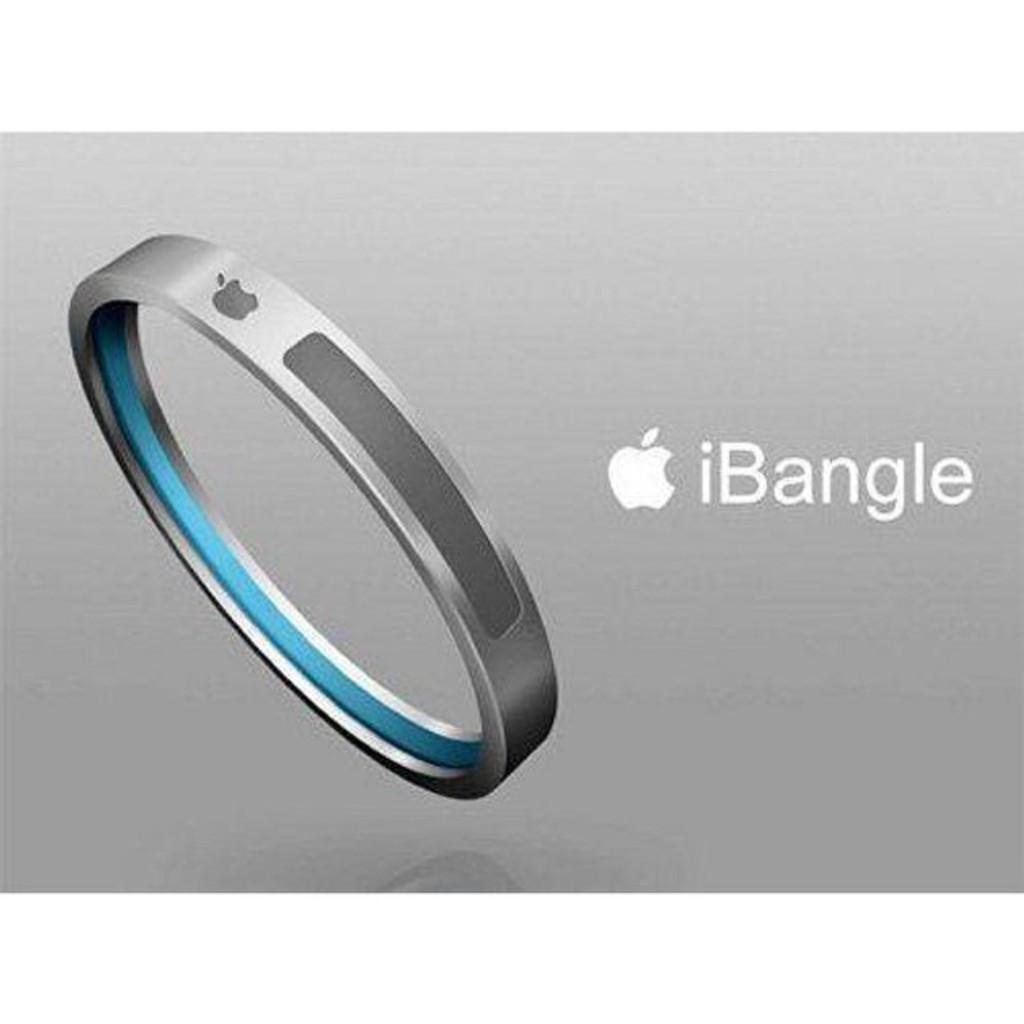<image>
Give a short and clear explanation of the subsequent image. An Apple bracelet and the words IBangle written to the right. 